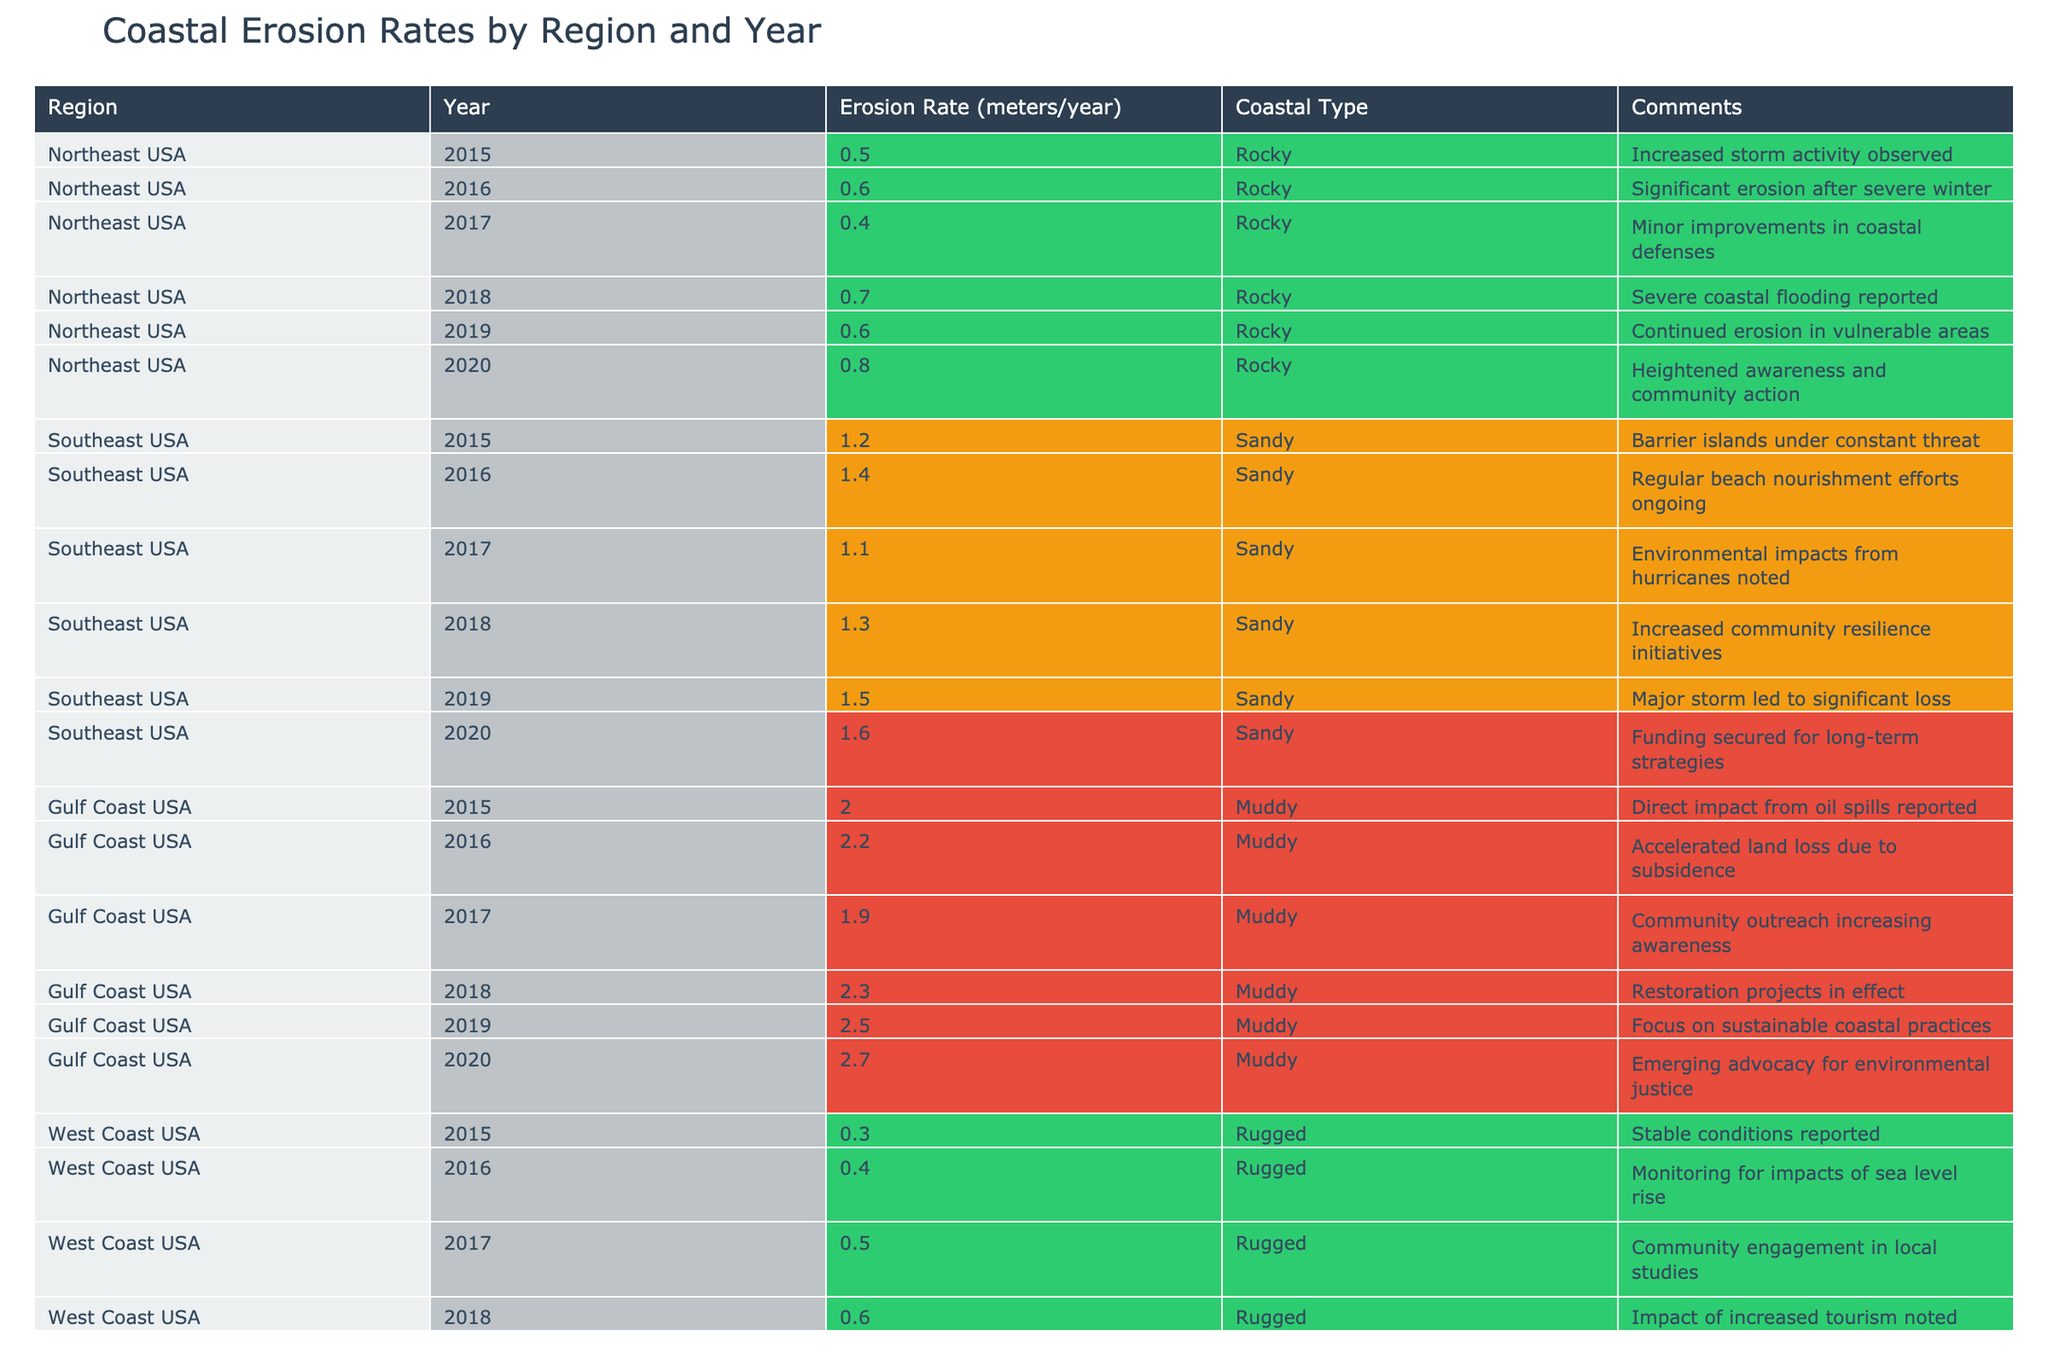What was the highest erosion rate recorded for the Gulf Coast in 2020? The table indicates that for the Gulf Coast in 2020, the erosion rate was 2.7 meters/year, which is the highest value for that year across all regions.
Answer: 2.7 Which region experienced the most significant increase in erosion rate from 2015 to 2020? By comparing the erosion rates for each region in 2015 and 2020, the Gulf Coast increased from 2.0 to 2.7 meters/year, a rise of 0.7 meters, which is higher than any other region's increase.
Answer: Gulf Coast Is the erosion rate for the Northeast USA higher in 2018 than in 2019? For the Northeast USA, the erosion rate was 0.7 meters/year in 2018 and 0.6 meters/year in 2019, which confirms that the rate was indeed higher in 2018.
Answer: Yes What is the average erosion rate for the Southeast USA from 2015 to 2020? The erosion rates for the Southeast USA for the years involved are: 1.2, 1.4, 1.1, 1.3, 1.5, and 1.6 meters/year. Summing these values gives 7.1 meters. Dividing by the number of years (6), the average is 7.1/6 ≈ 1.18 meters/year.
Answer: 1.18 Did the West Coast show a consistent increase in erosion rates from 2015 to 2020? Examining the West Coast rates, we see: 0.3, 0.4, 0.5, 0.6, 0.8, and 0.9 meters/year. This data shows a consistent increase year over year, confirming the trend.
Answer: Yes Which coastal type in the Northeast USA has shown the least erosion rate in 2017 and what is that rate? The table indicates the erosion rate for the Northeast USA in 2017 is 0.4 meters/year. Compared to other years in the Northeast, this is indeed the lowest rate for that region in the provided data.
Answer: 0.4 How much higher was the erosion rate on the Gulf Coast in 2019 compared to the West Coast? The Gulf Coast's erosion rate in 2019 was 2.5 meters/year, while the West Coast's was 0.8 meters/year. The difference is calculated as 2.5 - 0.8 = 1.7 meters/year, showing a significant discrepancy between the two regions.
Answer: 1.7 What comments have been recorded for the increase in erosion rates on the Northeast USA in 2020? The comment for the Northeast USA in 2020 was "Heightened awareness and community action," indicating a community-driven response to increased erosion.
Answer: Heightened awareness and community action 